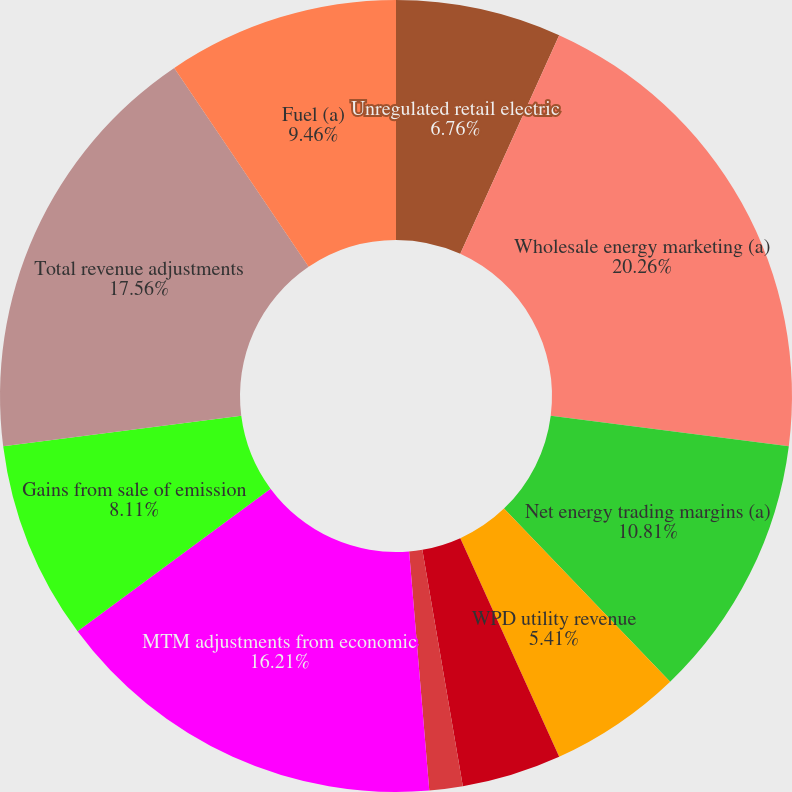<chart> <loc_0><loc_0><loc_500><loc_500><pie_chart><fcel>Unregulated retail electric<fcel>Wholesale energy marketing (a)<fcel>Net energy trading margins (a)<fcel>WPD utility revenue<fcel>Domestic delivery component of<fcel>Other utility revenue<fcel>MTM adjustments from economic<fcel>Gains from sale of emission<fcel>Total revenue adjustments<fcel>Fuel (a)<nl><fcel>6.76%<fcel>20.26%<fcel>10.81%<fcel>5.41%<fcel>4.06%<fcel>1.36%<fcel>16.21%<fcel>8.11%<fcel>17.56%<fcel>9.46%<nl></chart> 